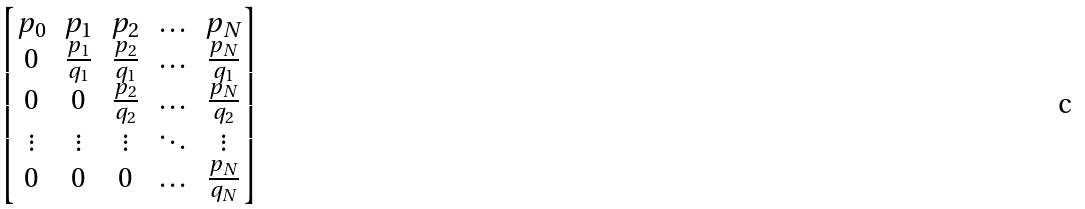<formula> <loc_0><loc_0><loc_500><loc_500>\begin{bmatrix} p _ { 0 } & p _ { 1 } & p _ { 2 } & \hdots & p _ { N } \\ 0 & \frac { p _ { 1 } } { q _ { 1 } } & \frac { p _ { 2 } } { q _ { 1 } } & \hdots & \frac { p _ { N } } { q _ { 1 } } \\ 0 & 0 & \frac { p _ { 2 } } { q _ { 2 } } & \hdots & \frac { p _ { N } } { q _ { 2 } } \\ \vdots & \vdots & \vdots & \ddots & \vdots \\ 0 & 0 & 0 & \hdots & \frac { p _ { N } } { q _ { N } } \end{bmatrix}</formula> 